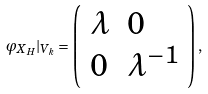Convert formula to latex. <formula><loc_0><loc_0><loc_500><loc_500>\varphi _ { X _ { H } } | _ { V _ { k } } = \left ( \begin{array} { l l } \lambda & 0 \\ 0 & \lambda ^ { - 1 } \end{array} \right ) ,</formula> 